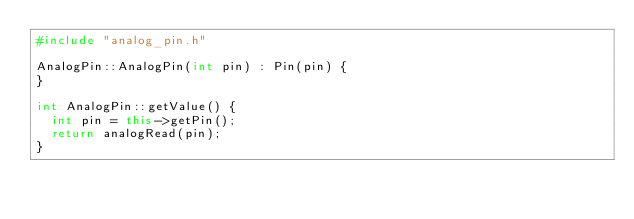<code> <loc_0><loc_0><loc_500><loc_500><_C++_>#include "analog_pin.h"

AnalogPin::AnalogPin(int pin) : Pin(pin) {
}

int AnalogPin::getValue() {
  int pin = this->getPin();
  return analogRead(pin);
}
</code> 